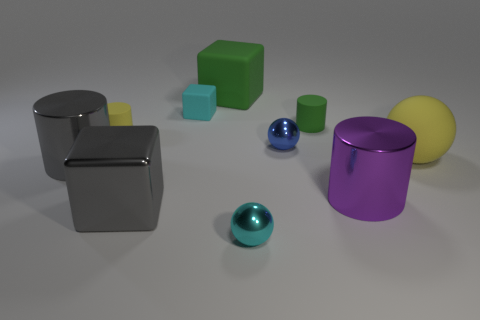Is the number of gray metal blocks that are behind the big gray block less than the number of red metal cylinders?
Ensure brevity in your answer.  No. Is there a blue sphere made of the same material as the purple thing?
Provide a short and direct response. Yes. There is a green cylinder; is it the same size as the yellow matte thing that is behind the yellow matte sphere?
Your answer should be very brief. Yes. Are there any tiny cylinders of the same color as the shiny block?
Ensure brevity in your answer.  No. Is the blue object made of the same material as the small block?
Your answer should be very brief. No. How many large yellow matte balls are in front of the small yellow matte cylinder?
Ensure brevity in your answer.  1. There is a cylinder that is both behind the yellow sphere and to the right of the small cyan metal object; what is its material?
Offer a terse response. Rubber. What number of yellow objects are the same size as the gray metal cylinder?
Your answer should be very brief. 1. There is a tiny rubber object on the right side of the tiny cyan object behind the large gray metallic cube; what is its color?
Keep it short and to the point. Green. Is there a small blue shiny object?
Keep it short and to the point. Yes. 